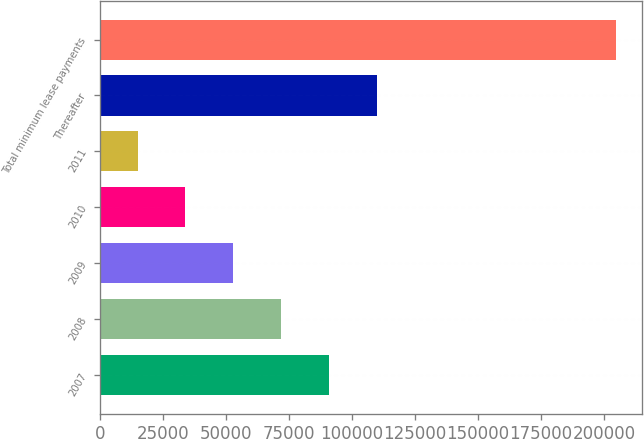Convert chart. <chart><loc_0><loc_0><loc_500><loc_500><bar_chart><fcel>2007<fcel>2008<fcel>2009<fcel>2010<fcel>2011<fcel>Thereafter<fcel>Total minimum lease payments<nl><fcel>90860<fcel>71870<fcel>52880<fcel>33890<fcel>14900<fcel>109850<fcel>204800<nl></chart> 